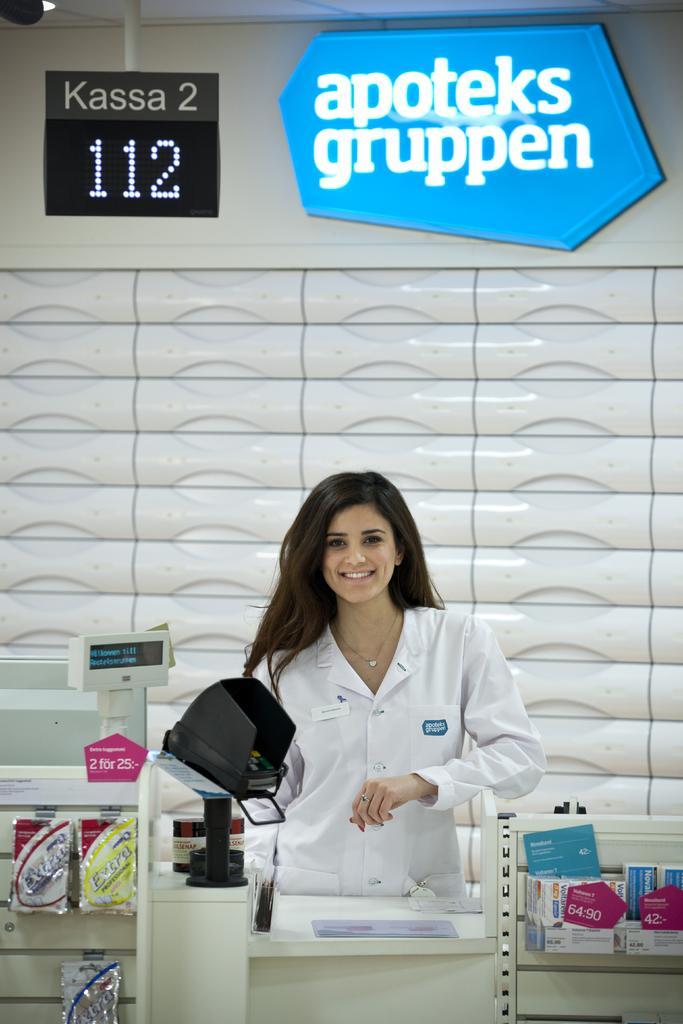Could you give a brief overview of what you see in this image? There is one woman wearing a white color dress and some other objects are present at the bottom of this image. We can see a wall in the background. There is a text board and a display board present at the top of this image. 